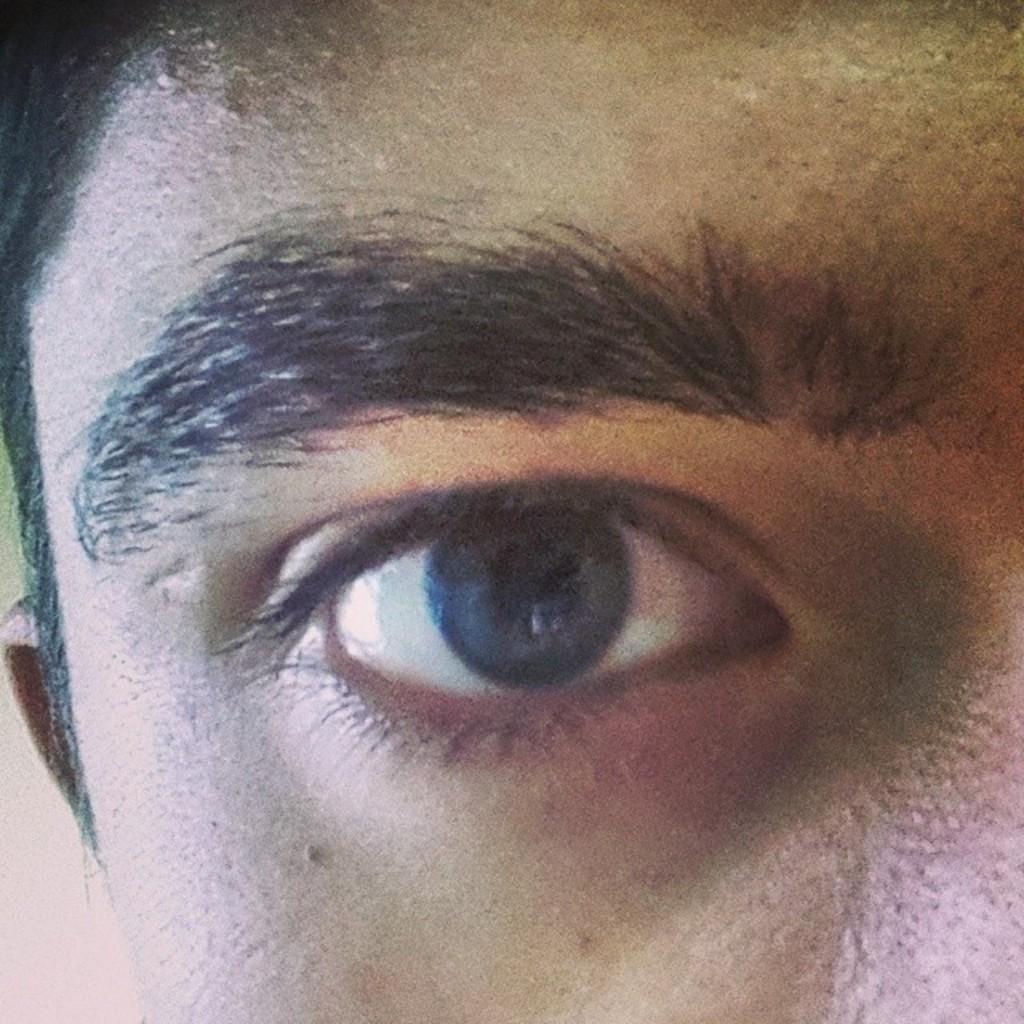Describe this image in one or two sentences. In this picture I can see a person's face and I see an eye and I see the eyebrows. On the left side of this picture I see the hair and an ear. 